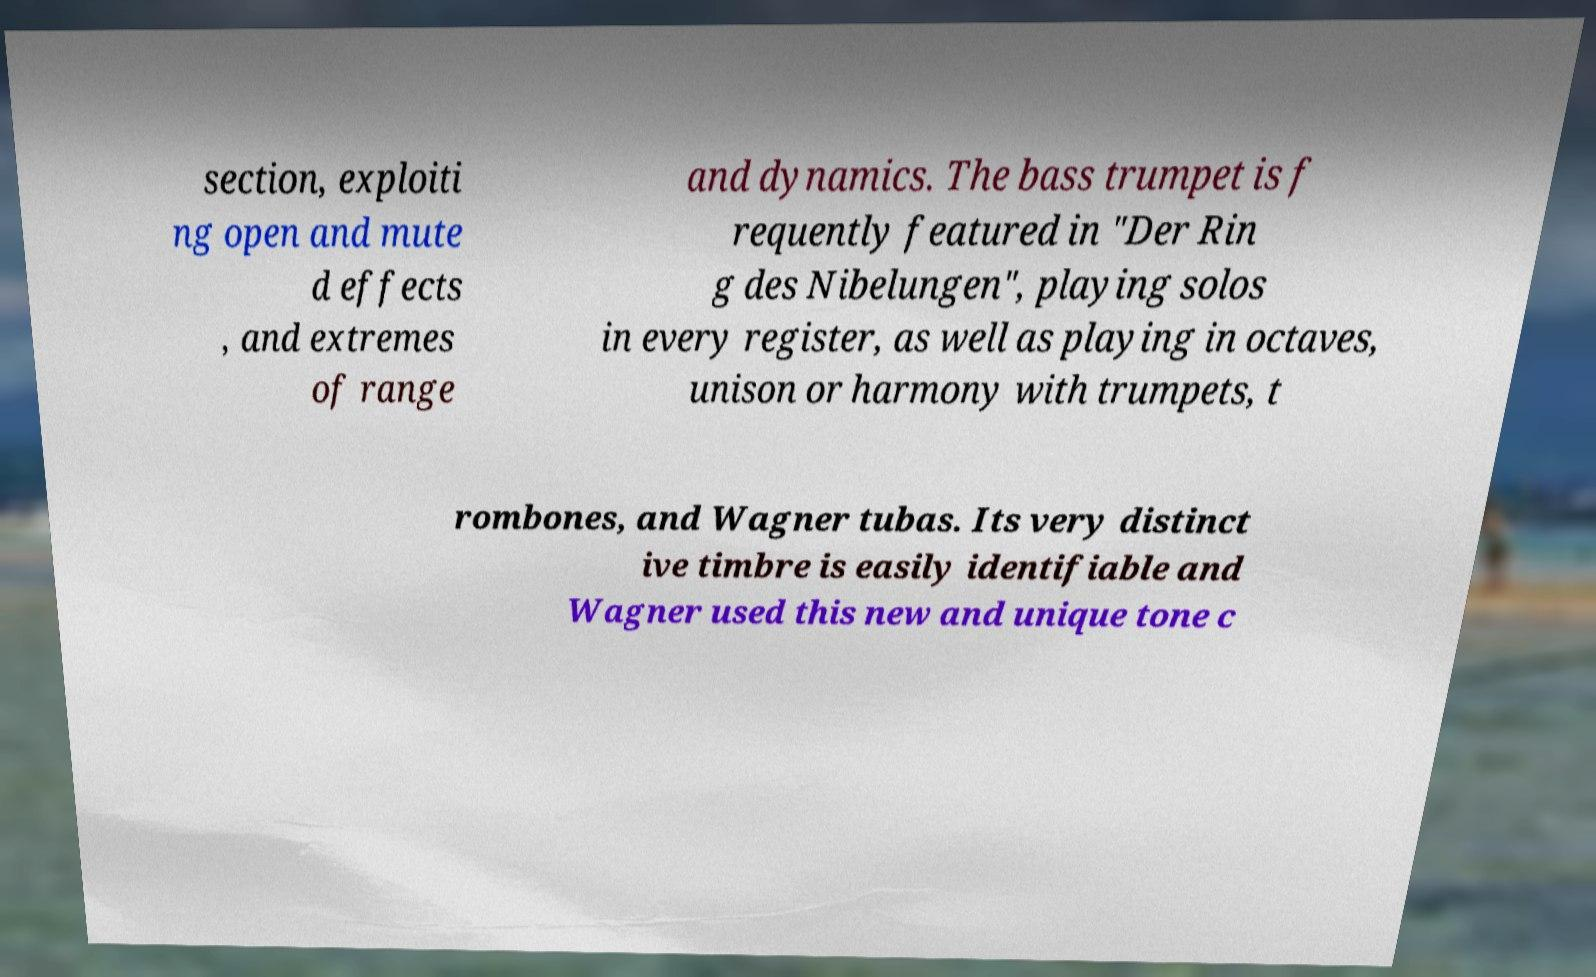Can you read and provide the text displayed in the image?This photo seems to have some interesting text. Can you extract and type it out for me? section, exploiti ng open and mute d effects , and extremes of range and dynamics. The bass trumpet is f requently featured in "Der Rin g des Nibelungen", playing solos in every register, as well as playing in octaves, unison or harmony with trumpets, t rombones, and Wagner tubas. Its very distinct ive timbre is easily identifiable and Wagner used this new and unique tone c 